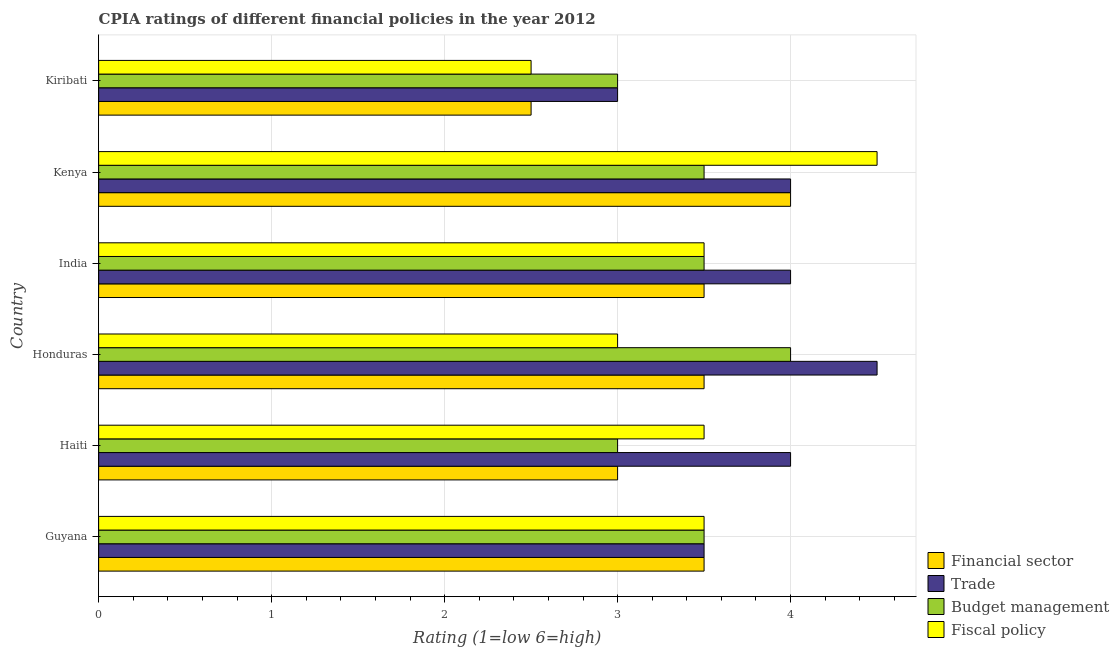How many different coloured bars are there?
Your answer should be compact. 4. Are the number of bars on each tick of the Y-axis equal?
Give a very brief answer. Yes. How many bars are there on the 5th tick from the top?
Your answer should be very brief. 4. What is the label of the 4th group of bars from the top?
Offer a terse response. Honduras. In how many cases, is the number of bars for a given country not equal to the number of legend labels?
Ensure brevity in your answer.  0. Across all countries, what is the minimum cpia rating of financial sector?
Your answer should be compact. 2.5. In which country was the cpia rating of fiscal policy maximum?
Your answer should be very brief. Kenya. In which country was the cpia rating of budget management minimum?
Offer a terse response. Haiti. What is the difference between the cpia rating of fiscal policy in Haiti and the cpia rating of trade in India?
Make the answer very short. -0.5. What is the average cpia rating of financial sector per country?
Your answer should be very brief. 3.33. In how many countries, is the cpia rating of financial sector greater than 3 ?
Provide a succinct answer. 4. What is the ratio of the cpia rating of trade in Guyana to that in Honduras?
Offer a very short reply. 0.78. What is the difference between the highest and the second highest cpia rating of budget management?
Your answer should be compact. 0.5. In how many countries, is the cpia rating of fiscal policy greater than the average cpia rating of fiscal policy taken over all countries?
Your answer should be very brief. 4. What does the 2nd bar from the top in Honduras represents?
Provide a succinct answer. Budget management. What does the 1st bar from the bottom in Guyana represents?
Your answer should be very brief. Financial sector. Are all the bars in the graph horizontal?
Your answer should be compact. Yes. Does the graph contain any zero values?
Offer a terse response. No. Does the graph contain grids?
Offer a very short reply. Yes. Where does the legend appear in the graph?
Keep it short and to the point. Bottom right. How are the legend labels stacked?
Offer a terse response. Vertical. What is the title of the graph?
Offer a very short reply. CPIA ratings of different financial policies in the year 2012. What is the label or title of the X-axis?
Keep it short and to the point. Rating (1=low 6=high). What is the label or title of the Y-axis?
Provide a succinct answer. Country. What is the Rating (1=low 6=high) in Financial sector in Guyana?
Your answer should be compact. 3.5. What is the Rating (1=low 6=high) in Trade in Guyana?
Your answer should be very brief. 3.5. What is the Rating (1=low 6=high) in Budget management in Guyana?
Provide a succinct answer. 3.5. What is the Rating (1=low 6=high) of Financial sector in Haiti?
Provide a short and direct response. 3. What is the Rating (1=low 6=high) in Trade in Haiti?
Keep it short and to the point. 4. What is the Rating (1=low 6=high) in Budget management in Haiti?
Give a very brief answer. 3. What is the Rating (1=low 6=high) of Fiscal policy in Honduras?
Provide a succinct answer. 3. What is the Rating (1=low 6=high) of Trade in India?
Give a very brief answer. 4. What is the Rating (1=low 6=high) of Financial sector in Kenya?
Your response must be concise. 4. What is the Rating (1=low 6=high) of Trade in Kiribati?
Make the answer very short. 3. What is the Rating (1=low 6=high) of Fiscal policy in Kiribati?
Make the answer very short. 2.5. Across all countries, what is the maximum Rating (1=low 6=high) in Financial sector?
Offer a terse response. 4. Across all countries, what is the maximum Rating (1=low 6=high) of Budget management?
Keep it short and to the point. 4. Across all countries, what is the minimum Rating (1=low 6=high) of Budget management?
Provide a succinct answer. 3. Across all countries, what is the minimum Rating (1=low 6=high) of Fiscal policy?
Keep it short and to the point. 2.5. What is the total Rating (1=low 6=high) in Financial sector in the graph?
Give a very brief answer. 20. What is the difference between the Rating (1=low 6=high) in Financial sector in Guyana and that in Haiti?
Ensure brevity in your answer.  0.5. What is the difference between the Rating (1=low 6=high) of Budget management in Guyana and that in Haiti?
Ensure brevity in your answer.  0.5. What is the difference between the Rating (1=low 6=high) of Financial sector in Guyana and that in Honduras?
Your answer should be compact. 0. What is the difference between the Rating (1=low 6=high) in Trade in Guyana and that in Honduras?
Offer a terse response. -1. What is the difference between the Rating (1=low 6=high) in Budget management in Guyana and that in Honduras?
Your answer should be compact. -0.5. What is the difference between the Rating (1=low 6=high) of Fiscal policy in Guyana and that in Honduras?
Your answer should be very brief. 0.5. What is the difference between the Rating (1=low 6=high) of Trade in Guyana and that in India?
Give a very brief answer. -0.5. What is the difference between the Rating (1=low 6=high) of Fiscal policy in Guyana and that in India?
Provide a succinct answer. 0. What is the difference between the Rating (1=low 6=high) in Trade in Guyana and that in Kenya?
Provide a short and direct response. -0.5. What is the difference between the Rating (1=low 6=high) in Budget management in Guyana and that in Kiribati?
Your answer should be compact. 0.5. What is the difference between the Rating (1=low 6=high) of Fiscal policy in Guyana and that in Kiribati?
Offer a terse response. 1. What is the difference between the Rating (1=low 6=high) of Financial sector in Haiti and that in Honduras?
Ensure brevity in your answer.  -0.5. What is the difference between the Rating (1=low 6=high) in Budget management in Haiti and that in Honduras?
Keep it short and to the point. -1. What is the difference between the Rating (1=low 6=high) of Fiscal policy in Haiti and that in Honduras?
Keep it short and to the point. 0.5. What is the difference between the Rating (1=low 6=high) in Financial sector in Haiti and that in Kiribati?
Make the answer very short. 0.5. What is the difference between the Rating (1=low 6=high) of Budget management in Haiti and that in Kiribati?
Give a very brief answer. 0. What is the difference between the Rating (1=low 6=high) of Financial sector in Honduras and that in India?
Ensure brevity in your answer.  0. What is the difference between the Rating (1=low 6=high) of Trade in Honduras and that in India?
Keep it short and to the point. 0.5. What is the difference between the Rating (1=low 6=high) in Fiscal policy in Honduras and that in India?
Your answer should be compact. -0.5. What is the difference between the Rating (1=low 6=high) in Financial sector in Honduras and that in Kenya?
Your answer should be compact. -0.5. What is the difference between the Rating (1=low 6=high) of Trade in Honduras and that in Kenya?
Your answer should be compact. 0.5. What is the difference between the Rating (1=low 6=high) in Fiscal policy in Honduras and that in Kenya?
Offer a terse response. -1.5. What is the difference between the Rating (1=low 6=high) in Budget management in Honduras and that in Kiribati?
Provide a short and direct response. 1. What is the difference between the Rating (1=low 6=high) of Fiscal policy in Honduras and that in Kiribati?
Your answer should be very brief. 0.5. What is the difference between the Rating (1=low 6=high) of Budget management in India and that in Kenya?
Ensure brevity in your answer.  0. What is the difference between the Rating (1=low 6=high) of Trade in India and that in Kiribati?
Keep it short and to the point. 1. What is the difference between the Rating (1=low 6=high) of Fiscal policy in India and that in Kiribati?
Keep it short and to the point. 1. What is the difference between the Rating (1=low 6=high) of Financial sector in Guyana and the Rating (1=low 6=high) of Fiscal policy in Haiti?
Give a very brief answer. 0. What is the difference between the Rating (1=low 6=high) of Trade in Guyana and the Rating (1=low 6=high) of Budget management in Haiti?
Your response must be concise. 0.5. What is the difference between the Rating (1=low 6=high) in Trade in Guyana and the Rating (1=low 6=high) in Fiscal policy in Haiti?
Offer a very short reply. 0. What is the difference between the Rating (1=low 6=high) in Budget management in Guyana and the Rating (1=low 6=high) in Fiscal policy in Haiti?
Provide a short and direct response. 0. What is the difference between the Rating (1=low 6=high) of Trade in Guyana and the Rating (1=low 6=high) of Fiscal policy in Honduras?
Provide a succinct answer. 0.5. What is the difference between the Rating (1=low 6=high) of Budget management in Guyana and the Rating (1=low 6=high) of Fiscal policy in Honduras?
Provide a succinct answer. 0.5. What is the difference between the Rating (1=low 6=high) in Financial sector in Guyana and the Rating (1=low 6=high) in Budget management in India?
Make the answer very short. 0. What is the difference between the Rating (1=low 6=high) of Financial sector in Guyana and the Rating (1=low 6=high) of Fiscal policy in India?
Offer a terse response. 0. What is the difference between the Rating (1=low 6=high) of Financial sector in Guyana and the Rating (1=low 6=high) of Fiscal policy in Kenya?
Your answer should be very brief. -1. What is the difference between the Rating (1=low 6=high) of Trade in Guyana and the Rating (1=low 6=high) of Budget management in Kenya?
Give a very brief answer. 0. What is the difference between the Rating (1=low 6=high) in Trade in Guyana and the Rating (1=low 6=high) in Fiscal policy in Kenya?
Keep it short and to the point. -1. What is the difference between the Rating (1=low 6=high) in Financial sector in Guyana and the Rating (1=low 6=high) in Trade in Kiribati?
Your response must be concise. 0.5. What is the difference between the Rating (1=low 6=high) in Financial sector in Guyana and the Rating (1=low 6=high) in Fiscal policy in Kiribati?
Provide a short and direct response. 1. What is the difference between the Rating (1=low 6=high) of Trade in Guyana and the Rating (1=low 6=high) of Budget management in Kiribati?
Your response must be concise. 0.5. What is the difference between the Rating (1=low 6=high) of Trade in Guyana and the Rating (1=low 6=high) of Fiscal policy in Kiribati?
Ensure brevity in your answer.  1. What is the difference between the Rating (1=low 6=high) of Budget management in Guyana and the Rating (1=low 6=high) of Fiscal policy in Kiribati?
Make the answer very short. 1. What is the difference between the Rating (1=low 6=high) in Financial sector in Haiti and the Rating (1=low 6=high) in Budget management in Honduras?
Give a very brief answer. -1. What is the difference between the Rating (1=low 6=high) in Financial sector in Haiti and the Rating (1=low 6=high) in Fiscal policy in Honduras?
Ensure brevity in your answer.  0. What is the difference between the Rating (1=low 6=high) in Budget management in Haiti and the Rating (1=low 6=high) in Fiscal policy in Honduras?
Your answer should be compact. 0. What is the difference between the Rating (1=low 6=high) of Financial sector in Haiti and the Rating (1=low 6=high) of Fiscal policy in India?
Offer a terse response. -0.5. What is the difference between the Rating (1=low 6=high) of Trade in Haiti and the Rating (1=low 6=high) of Fiscal policy in India?
Keep it short and to the point. 0.5. What is the difference between the Rating (1=low 6=high) in Budget management in Haiti and the Rating (1=low 6=high) in Fiscal policy in India?
Keep it short and to the point. -0.5. What is the difference between the Rating (1=low 6=high) of Trade in Haiti and the Rating (1=low 6=high) of Budget management in Kenya?
Provide a short and direct response. 0.5. What is the difference between the Rating (1=low 6=high) of Budget management in Haiti and the Rating (1=low 6=high) of Fiscal policy in Kenya?
Offer a very short reply. -1.5. What is the difference between the Rating (1=low 6=high) of Financial sector in Haiti and the Rating (1=low 6=high) of Trade in Kiribati?
Provide a succinct answer. 0. What is the difference between the Rating (1=low 6=high) of Financial sector in Haiti and the Rating (1=low 6=high) of Budget management in Kiribati?
Make the answer very short. 0. What is the difference between the Rating (1=low 6=high) in Trade in Haiti and the Rating (1=low 6=high) in Fiscal policy in Kiribati?
Your answer should be compact. 1.5. What is the difference between the Rating (1=low 6=high) in Financial sector in Honduras and the Rating (1=low 6=high) in Budget management in India?
Your response must be concise. 0. What is the difference between the Rating (1=low 6=high) of Financial sector in Honduras and the Rating (1=low 6=high) of Fiscal policy in India?
Offer a very short reply. 0. What is the difference between the Rating (1=low 6=high) in Trade in Honduras and the Rating (1=low 6=high) in Budget management in India?
Offer a terse response. 1. What is the difference between the Rating (1=low 6=high) of Trade in Honduras and the Rating (1=low 6=high) of Fiscal policy in India?
Provide a short and direct response. 1. What is the difference between the Rating (1=low 6=high) in Budget management in Honduras and the Rating (1=low 6=high) in Fiscal policy in Kenya?
Offer a terse response. -0.5. What is the difference between the Rating (1=low 6=high) in Trade in Honduras and the Rating (1=low 6=high) in Budget management in Kiribati?
Keep it short and to the point. 1.5. What is the difference between the Rating (1=low 6=high) in Trade in Honduras and the Rating (1=low 6=high) in Fiscal policy in Kiribati?
Provide a succinct answer. 2. What is the difference between the Rating (1=low 6=high) in Budget management in Honduras and the Rating (1=low 6=high) in Fiscal policy in Kiribati?
Give a very brief answer. 1.5. What is the difference between the Rating (1=low 6=high) of Financial sector in India and the Rating (1=low 6=high) of Trade in Kenya?
Your answer should be very brief. -0.5. What is the difference between the Rating (1=low 6=high) of Financial sector in India and the Rating (1=low 6=high) of Budget management in Kenya?
Ensure brevity in your answer.  0. What is the difference between the Rating (1=low 6=high) of Financial sector in India and the Rating (1=low 6=high) of Fiscal policy in Kenya?
Your answer should be compact. -1. What is the difference between the Rating (1=low 6=high) of Trade in India and the Rating (1=low 6=high) of Budget management in Kenya?
Provide a short and direct response. 0.5. What is the difference between the Rating (1=low 6=high) in Trade in India and the Rating (1=low 6=high) in Fiscal policy in Kenya?
Provide a short and direct response. -0.5. What is the difference between the Rating (1=low 6=high) of Budget management in India and the Rating (1=low 6=high) of Fiscal policy in Kenya?
Your response must be concise. -1. What is the difference between the Rating (1=low 6=high) of Financial sector in India and the Rating (1=low 6=high) of Trade in Kiribati?
Keep it short and to the point. 0.5. What is the difference between the Rating (1=low 6=high) of Financial sector in India and the Rating (1=low 6=high) of Budget management in Kiribati?
Ensure brevity in your answer.  0.5. What is the difference between the Rating (1=low 6=high) in Financial sector in India and the Rating (1=low 6=high) in Fiscal policy in Kiribati?
Offer a very short reply. 1. What is the difference between the Rating (1=low 6=high) in Trade in India and the Rating (1=low 6=high) in Budget management in Kiribati?
Offer a terse response. 1. What is the difference between the Rating (1=low 6=high) of Trade in India and the Rating (1=low 6=high) of Fiscal policy in Kiribati?
Provide a succinct answer. 1.5. What is the difference between the Rating (1=low 6=high) in Budget management in India and the Rating (1=low 6=high) in Fiscal policy in Kiribati?
Keep it short and to the point. 1. What is the difference between the Rating (1=low 6=high) of Financial sector in Kenya and the Rating (1=low 6=high) of Trade in Kiribati?
Offer a terse response. 1. What is the difference between the Rating (1=low 6=high) of Financial sector in Kenya and the Rating (1=low 6=high) of Fiscal policy in Kiribati?
Offer a terse response. 1.5. What is the difference between the Rating (1=low 6=high) in Budget management in Kenya and the Rating (1=low 6=high) in Fiscal policy in Kiribati?
Make the answer very short. 1. What is the average Rating (1=low 6=high) of Trade per country?
Give a very brief answer. 3.83. What is the average Rating (1=low 6=high) in Budget management per country?
Your response must be concise. 3.42. What is the average Rating (1=low 6=high) of Fiscal policy per country?
Your answer should be compact. 3.42. What is the difference between the Rating (1=low 6=high) in Financial sector and Rating (1=low 6=high) in Trade in Guyana?
Offer a terse response. 0. What is the difference between the Rating (1=low 6=high) in Financial sector and Rating (1=low 6=high) in Budget management in Guyana?
Make the answer very short. 0. What is the difference between the Rating (1=low 6=high) in Financial sector and Rating (1=low 6=high) in Fiscal policy in Guyana?
Your answer should be compact. 0. What is the difference between the Rating (1=low 6=high) in Trade and Rating (1=low 6=high) in Budget management in Guyana?
Offer a very short reply. 0. What is the difference between the Rating (1=low 6=high) in Trade and Rating (1=low 6=high) in Budget management in Haiti?
Provide a short and direct response. 1. What is the difference between the Rating (1=low 6=high) of Trade and Rating (1=low 6=high) of Fiscal policy in Haiti?
Provide a short and direct response. 0.5. What is the difference between the Rating (1=low 6=high) of Budget management and Rating (1=low 6=high) of Fiscal policy in Haiti?
Your response must be concise. -0.5. What is the difference between the Rating (1=low 6=high) of Financial sector and Rating (1=low 6=high) of Fiscal policy in Honduras?
Your response must be concise. 0.5. What is the difference between the Rating (1=low 6=high) in Trade and Rating (1=low 6=high) in Budget management in Honduras?
Ensure brevity in your answer.  0.5. What is the difference between the Rating (1=low 6=high) of Trade and Rating (1=low 6=high) of Fiscal policy in Honduras?
Your answer should be compact. 1.5. What is the difference between the Rating (1=low 6=high) in Budget management and Rating (1=low 6=high) in Fiscal policy in Honduras?
Ensure brevity in your answer.  1. What is the difference between the Rating (1=low 6=high) of Financial sector and Rating (1=low 6=high) of Trade in India?
Keep it short and to the point. -0.5. What is the difference between the Rating (1=low 6=high) of Financial sector and Rating (1=low 6=high) of Budget management in India?
Give a very brief answer. 0. What is the difference between the Rating (1=low 6=high) in Trade and Rating (1=low 6=high) in Budget management in India?
Keep it short and to the point. 0.5. What is the difference between the Rating (1=low 6=high) of Trade and Rating (1=low 6=high) of Fiscal policy in India?
Your answer should be compact. 0.5. What is the difference between the Rating (1=low 6=high) in Budget management and Rating (1=low 6=high) in Fiscal policy in India?
Offer a terse response. 0. What is the difference between the Rating (1=low 6=high) in Financial sector and Rating (1=low 6=high) in Trade in Kenya?
Offer a very short reply. 0. What is the difference between the Rating (1=low 6=high) of Financial sector and Rating (1=low 6=high) of Budget management in Kenya?
Keep it short and to the point. 0.5. What is the difference between the Rating (1=low 6=high) in Trade and Rating (1=low 6=high) in Budget management in Kenya?
Offer a very short reply. 0.5. What is the difference between the Rating (1=low 6=high) in Trade and Rating (1=low 6=high) in Budget management in Kiribati?
Your answer should be compact. 0. What is the ratio of the Rating (1=low 6=high) in Fiscal policy in Guyana to that in Haiti?
Offer a very short reply. 1. What is the ratio of the Rating (1=low 6=high) of Financial sector in Guyana to that in Honduras?
Offer a terse response. 1. What is the ratio of the Rating (1=low 6=high) in Trade in Guyana to that in Honduras?
Your answer should be very brief. 0.78. What is the ratio of the Rating (1=low 6=high) of Fiscal policy in Guyana to that in Honduras?
Offer a terse response. 1.17. What is the ratio of the Rating (1=low 6=high) in Trade in Guyana to that in India?
Offer a very short reply. 0.88. What is the ratio of the Rating (1=low 6=high) in Fiscal policy in Guyana to that in India?
Your answer should be very brief. 1. What is the ratio of the Rating (1=low 6=high) in Trade in Guyana to that in Kenya?
Your answer should be compact. 0.88. What is the ratio of the Rating (1=low 6=high) in Budget management in Guyana to that in Kenya?
Your response must be concise. 1. What is the ratio of the Rating (1=low 6=high) of Financial sector in Haiti to that in Honduras?
Provide a short and direct response. 0.86. What is the ratio of the Rating (1=low 6=high) of Budget management in Haiti to that in Honduras?
Your answer should be very brief. 0.75. What is the ratio of the Rating (1=low 6=high) of Fiscal policy in Haiti to that in Honduras?
Ensure brevity in your answer.  1.17. What is the ratio of the Rating (1=low 6=high) of Financial sector in Haiti to that in India?
Offer a terse response. 0.86. What is the ratio of the Rating (1=low 6=high) of Trade in Haiti to that in India?
Your answer should be compact. 1. What is the ratio of the Rating (1=low 6=high) in Budget management in Haiti to that in India?
Provide a short and direct response. 0.86. What is the ratio of the Rating (1=low 6=high) in Financial sector in Haiti to that in Kenya?
Give a very brief answer. 0.75. What is the ratio of the Rating (1=low 6=high) of Trade in Haiti to that in Kenya?
Offer a very short reply. 1. What is the ratio of the Rating (1=low 6=high) in Budget management in Haiti to that in Kenya?
Make the answer very short. 0.86. What is the ratio of the Rating (1=low 6=high) in Fiscal policy in Haiti to that in Kenya?
Your answer should be very brief. 0.78. What is the ratio of the Rating (1=low 6=high) of Budget management in Haiti to that in Kiribati?
Ensure brevity in your answer.  1. What is the ratio of the Rating (1=low 6=high) of Trade in Honduras to that in Kenya?
Offer a terse response. 1.12. What is the ratio of the Rating (1=low 6=high) of Trade in Honduras to that in Kiribati?
Provide a short and direct response. 1.5. What is the ratio of the Rating (1=low 6=high) in Financial sector in India to that in Kenya?
Your answer should be very brief. 0.88. What is the ratio of the Rating (1=low 6=high) of Budget management in India to that in Kenya?
Offer a very short reply. 1. What is the ratio of the Rating (1=low 6=high) in Fiscal policy in India to that in Kenya?
Provide a succinct answer. 0.78. What is the ratio of the Rating (1=low 6=high) in Budget management in India to that in Kiribati?
Give a very brief answer. 1.17. What is the difference between the highest and the second highest Rating (1=low 6=high) in Financial sector?
Keep it short and to the point. 0.5. What is the difference between the highest and the second highest Rating (1=low 6=high) of Budget management?
Give a very brief answer. 0.5. What is the difference between the highest and the second highest Rating (1=low 6=high) of Fiscal policy?
Offer a very short reply. 1. What is the difference between the highest and the lowest Rating (1=low 6=high) in Financial sector?
Your answer should be compact. 1.5. What is the difference between the highest and the lowest Rating (1=low 6=high) in Trade?
Provide a succinct answer. 1.5. What is the difference between the highest and the lowest Rating (1=low 6=high) of Budget management?
Your answer should be very brief. 1. 